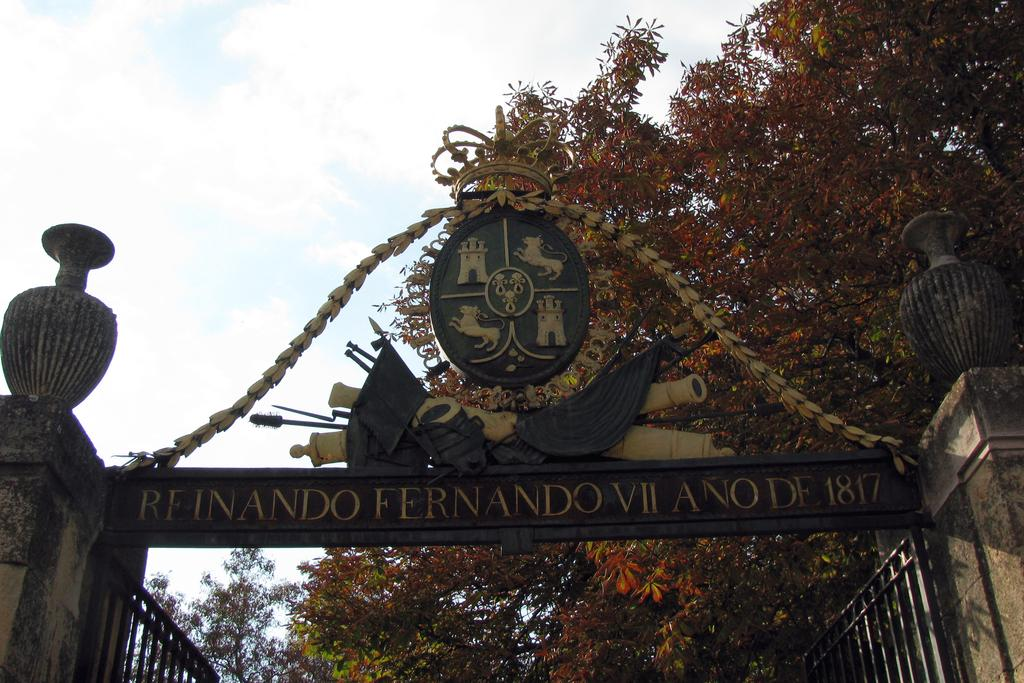<image>
Provide a brief description of the given image. A an open gate reads Reinando Fernando VII Ano 1817 above it 